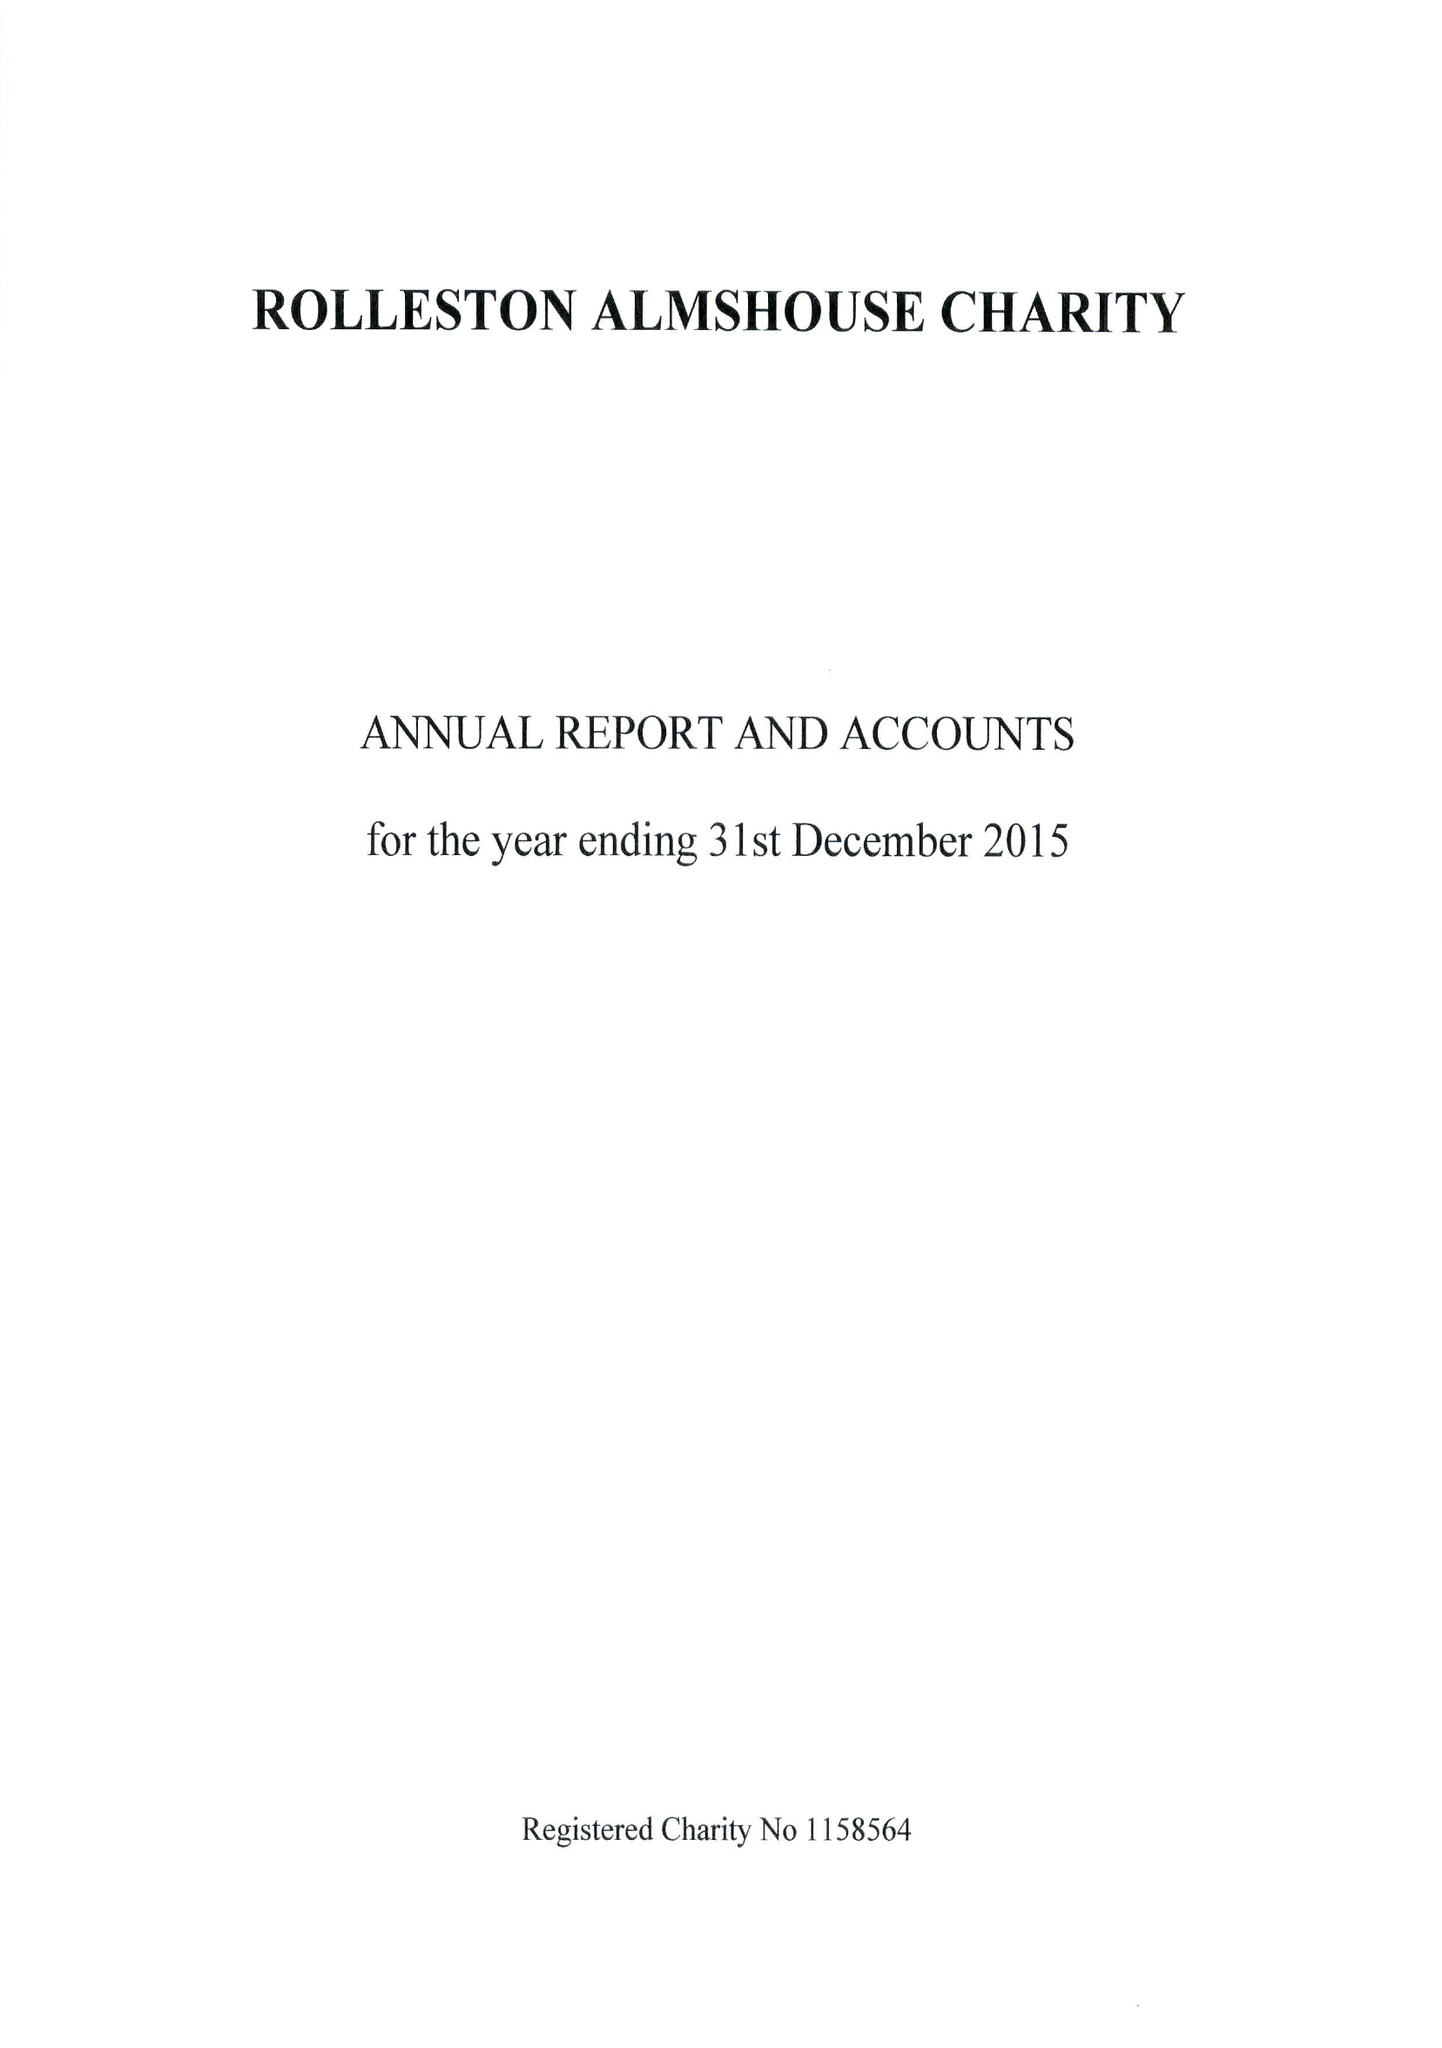What is the value for the charity_name?
Answer the question using a single word or phrase. Rolleston Almshouse Charity 